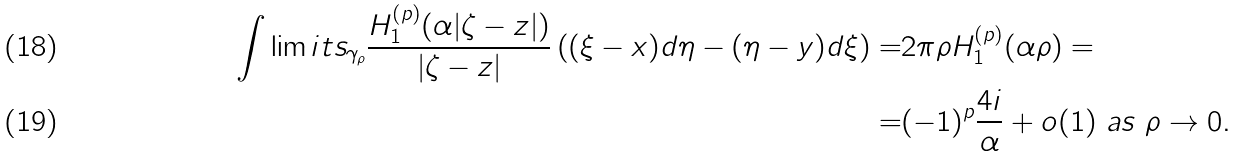Convert formula to latex. <formula><loc_0><loc_0><loc_500><loc_500>\int \lim i t s _ { \gamma _ { \rho } } \frac { H _ { 1 } ^ { ( p ) } ( \alpha | \zeta - z | ) } { | \zeta - z | } \left ( ( \xi - x ) d \eta - ( \eta - y ) d \xi \right ) = & 2 \pi \rho H _ { 1 } ^ { ( p ) } ( \alpha \rho ) = \\ = & ( - 1 ) ^ { p } \frac { 4 i } { \alpha } + o ( 1 ) \ a s \ \rho \to 0 .</formula> 